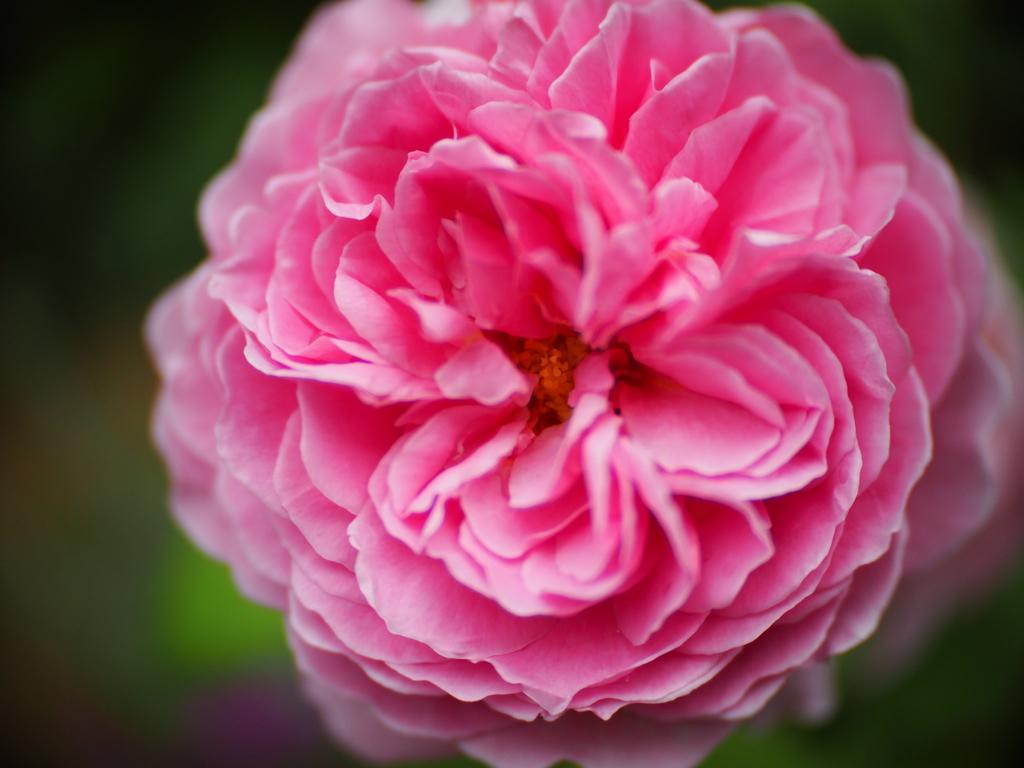What is the main subject of the image? There is a flower in the image. What color is the flower? The flower is pink. Can you describe the background of the image? The background of the image is blurred. Can you tell me how many people are swimming in the library in the image? There are no people swimming in a library in the image, as it features a pink flower with a blurred background. 